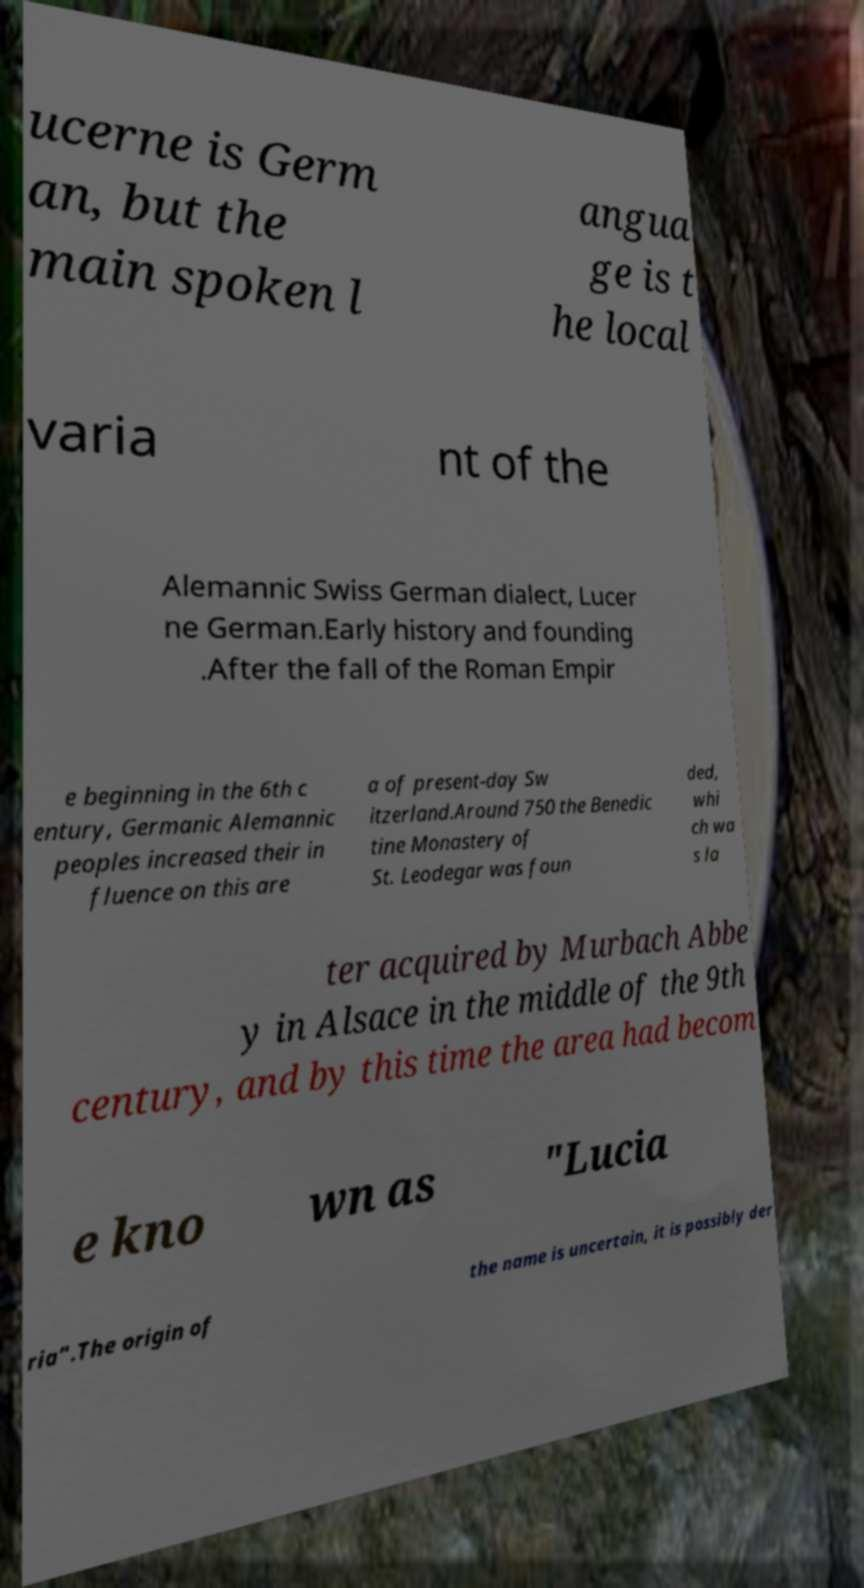What messages or text are displayed in this image? I need them in a readable, typed format. ucerne is Germ an, but the main spoken l angua ge is t he local varia nt of the Alemannic Swiss German dialect, Lucer ne German.Early history and founding .After the fall of the Roman Empir e beginning in the 6th c entury, Germanic Alemannic peoples increased their in fluence on this are a of present-day Sw itzerland.Around 750 the Benedic tine Monastery of St. Leodegar was foun ded, whi ch wa s la ter acquired by Murbach Abbe y in Alsace in the middle of the 9th century, and by this time the area had becom e kno wn as "Lucia ria".The origin of the name is uncertain, it is possibly der 